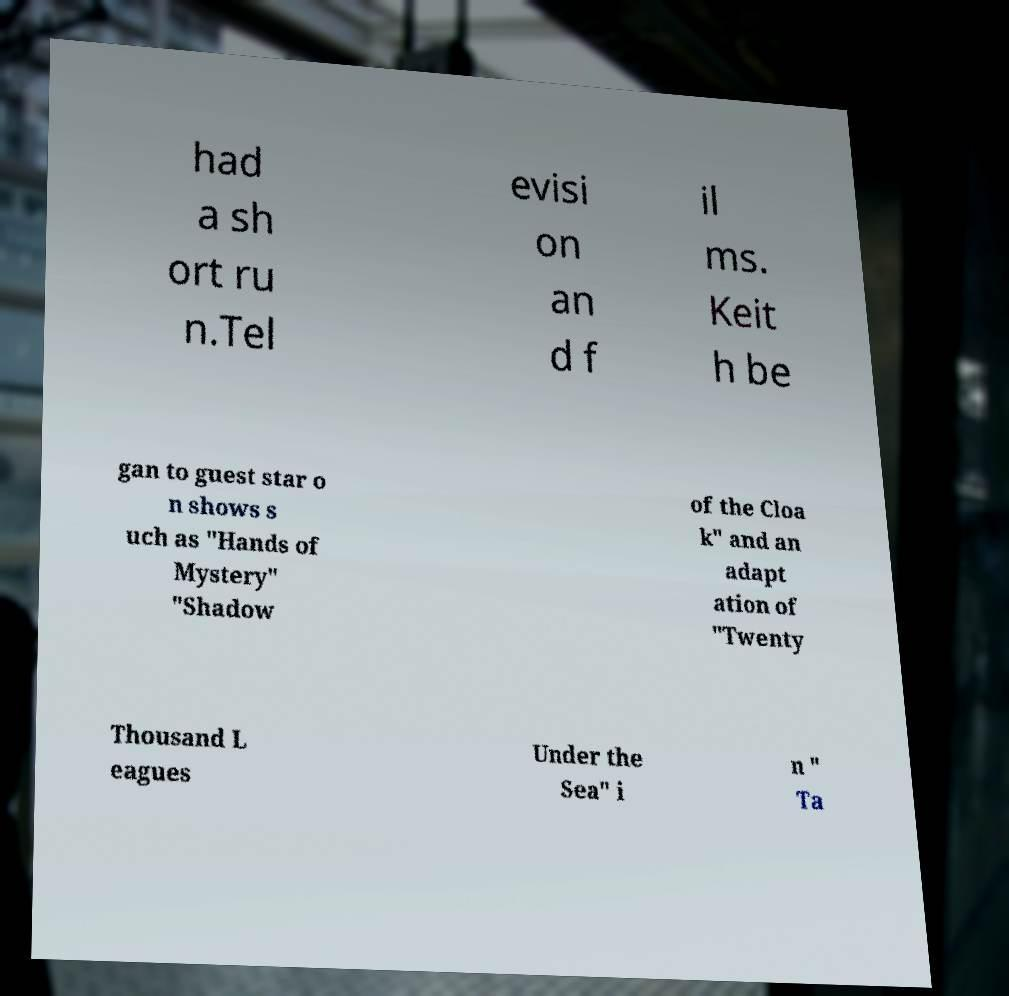Could you assist in decoding the text presented in this image and type it out clearly? had a sh ort ru n.Tel evisi on an d f il ms. Keit h be gan to guest star o n shows s uch as "Hands of Mystery" "Shadow of the Cloa k" and an adapt ation of "Twenty Thousand L eagues Under the Sea" i n " Ta 